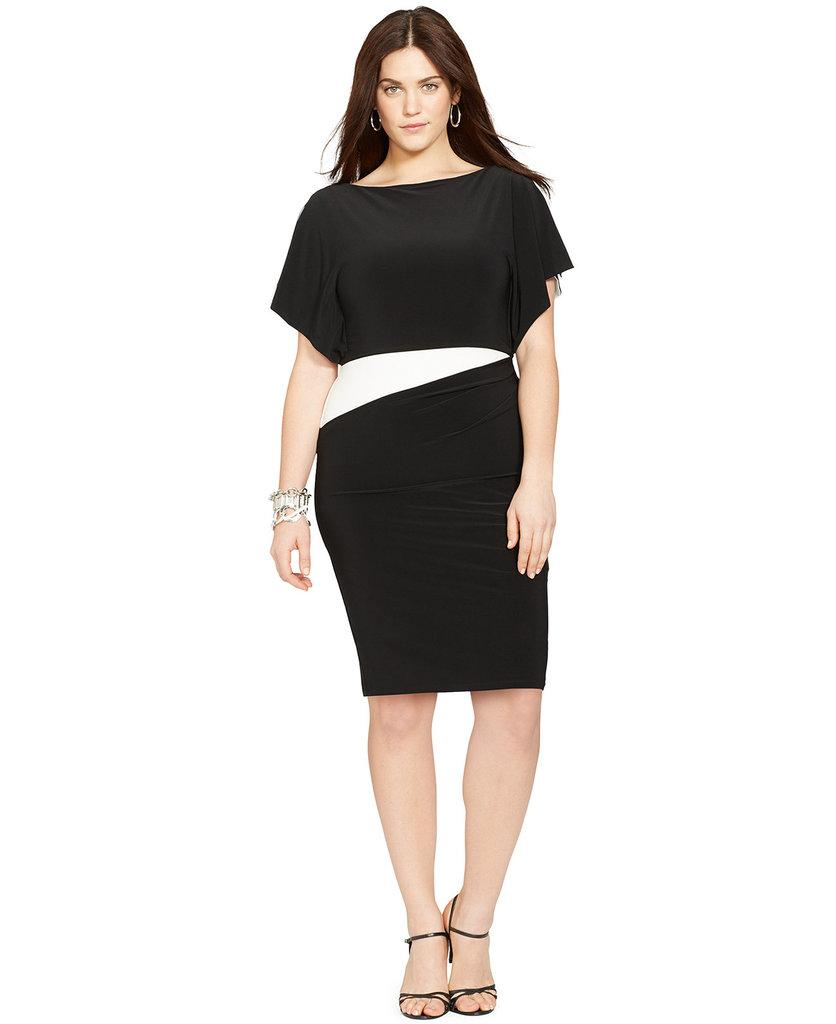What is the main subject in the image? There is a person standing in the image. What can be seen behind the person? There is a white background in the image. What type of business is being conducted in the image? There is no indication of any business being conducted in the image, as it only features a person standing against a white background. 